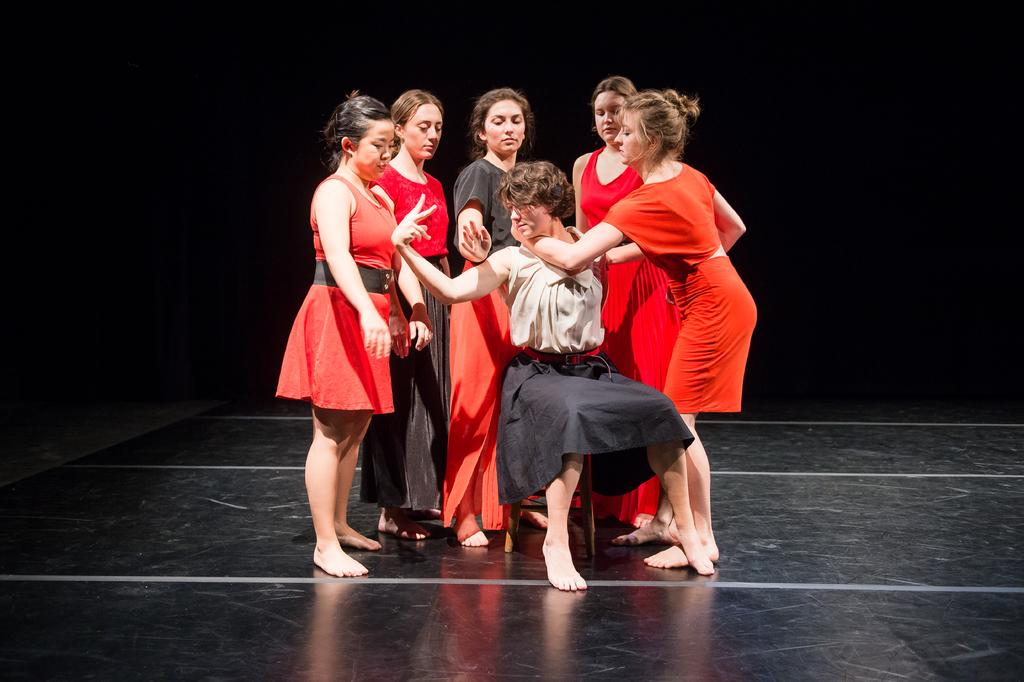What is the primary activity of the women in the image? The women are standing in the image. What surface are the women standing on? The women are standing on the floor. Can you describe the position of the person in the image? There is a person sitting on a chair in the image. What type of building can be seen in the background of the image? There is no building visible in the image; it only features the women standing and the person sitting on a chair. 